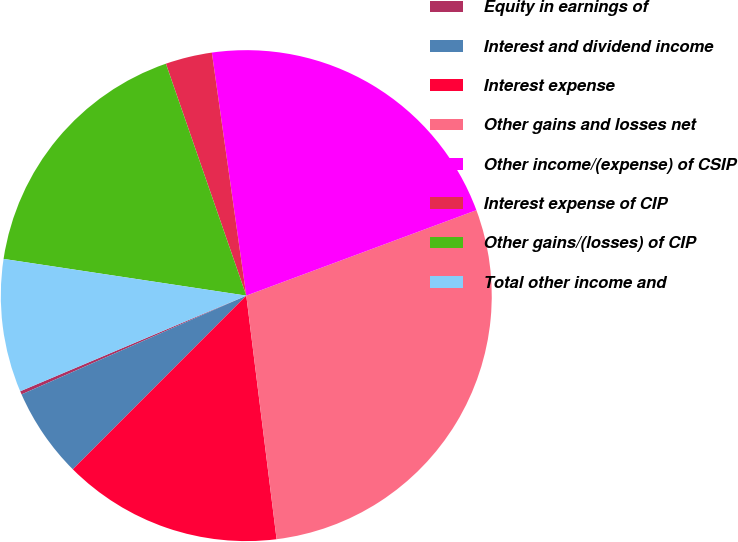<chart> <loc_0><loc_0><loc_500><loc_500><pie_chart><fcel>Equity in earnings of<fcel>Interest and dividend income<fcel>Interest expense<fcel>Other gains and losses net<fcel>Other income/(expense) of CSIP<fcel>Interest expense of CIP<fcel>Other gains/(losses) of CIP<fcel>Total other income and<nl><fcel>0.22%<fcel>5.92%<fcel>14.46%<fcel>28.69%<fcel>21.58%<fcel>3.07%<fcel>17.3%<fcel>8.76%<nl></chart> 